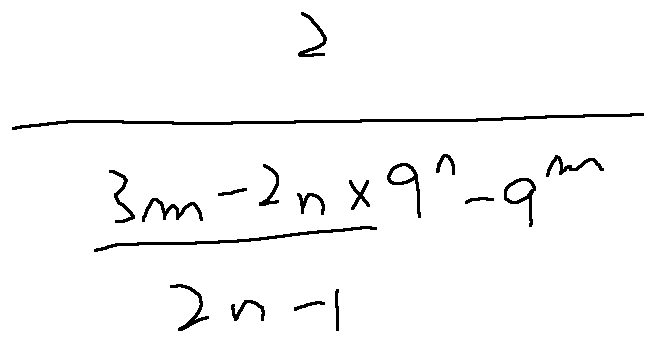Convert formula to latex. <formula><loc_0><loc_0><loc_500><loc_500>\frac { 2 } { \frac { 3 m - 2 n \times 9 ^ { n } - 9 ^ { m } } { 2 n - 1 } }</formula> 